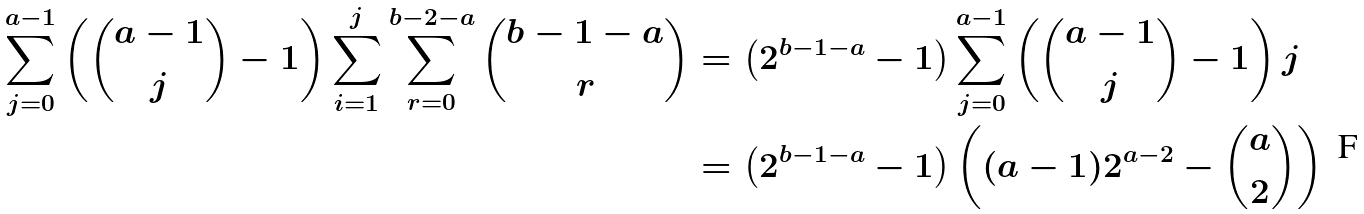Convert formula to latex. <formula><loc_0><loc_0><loc_500><loc_500>\sum _ { j = 0 } ^ { a - 1 } \left ( \binom { a - 1 } { j } - 1 \right ) \sum _ { i = 1 } ^ { j } \sum _ { r = 0 } ^ { b - 2 - a } \binom { b - 1 - a } { r } & = \left ( 2 ^ { b - 1 - a } - 1 \right ) \sum _ { j = 0 } ^ { a - 1 } \left ( \binom { a - 1 } { j } - 1 \right ) j \\ & = \left ( 2 ^ { b - 1 - a } - 1 \right ) \left ( ( a - 1 ) 2 ^ { a - 2 } - \binom { a } { 2 } \right )</formula> 